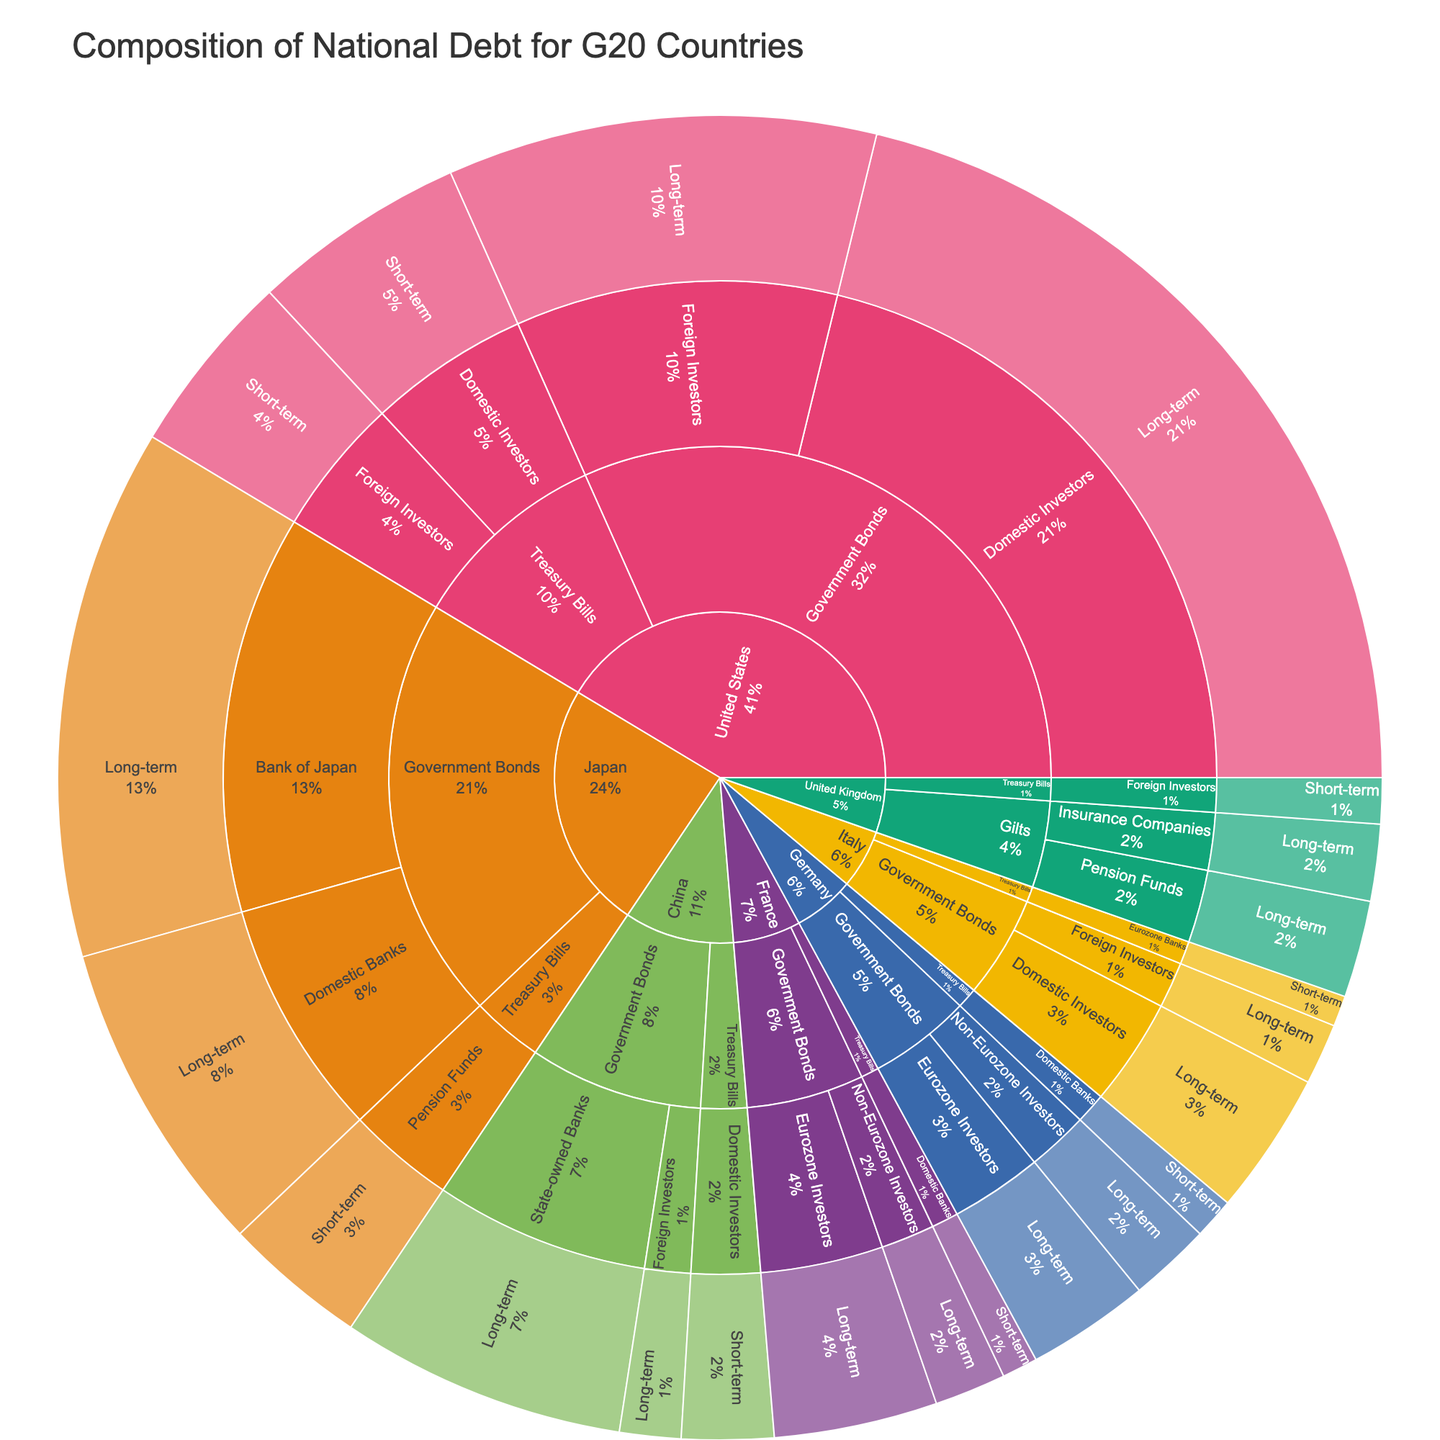What is the title of the sunburst plot? The title is written at the top of the plot and provides a summary of what the visual is depicting.
Answer: Composition of National Debt for G20 Countries Which country has the highest amount of Treasury Bills held by Foreign Investors? Look at the "Treasury Bills" section, then find the segment for "Foreign Investors" and identify the country with the largest segment.
Answer: United States What is the total value of Government Bonds for Japan? Sum the values of all segments under Government Bonds for Japan. The values are 5200 (Bank of Japan) + 3100 (Domestic Banks) = 8300.
Answer: 8300 Which country has the most diverse set of creditors for Government Bonds? Identify the country with the highest number of unique creditor segments under Government Bonds. The countries and their creditor counts are: United States (2), Japan (2), Germany (2), China (2), France (2), Italy (2). All have equal diversity.
Answer: Tied (US, Japan, Germany, China, France, Italy) What is the difference in value between Domestic Investors and Foreign Investors holding Government Bonds in the United States? Subtract the value of Foreign Investors from Domestic Investors for Government Bonds in the United States. The values are 8500 (Domestic Investors) - 4200 (Foreign Investors) = 4300.
Answer: 4300 Which country has the largest proportion of its national debt in the form of Short-term maturity instruments? Compare the total values of short-term maturity segments for each country and determine the largest one relative to their total debt.
Answer: United States How much national debt does China owe to Foreign Investors through Treasury Bills? Find the value in the Treasury Bills segment under China for Foreign Investors.
Answer: 0 What is the average value of Long-term Government Bonds among European countries represented? Sum the values of Long-term Government Bonds for European countries (Germany, United Kingdom, France, Italy) and divide by the number of countries. Values are 1200 + 800 (Germany) + 950 + 750 (UK) + 1600 + 700 (France) + 1400 + 600 (Italy) = 7300 divided by 4 countries = 1825.
Answer: 1825 